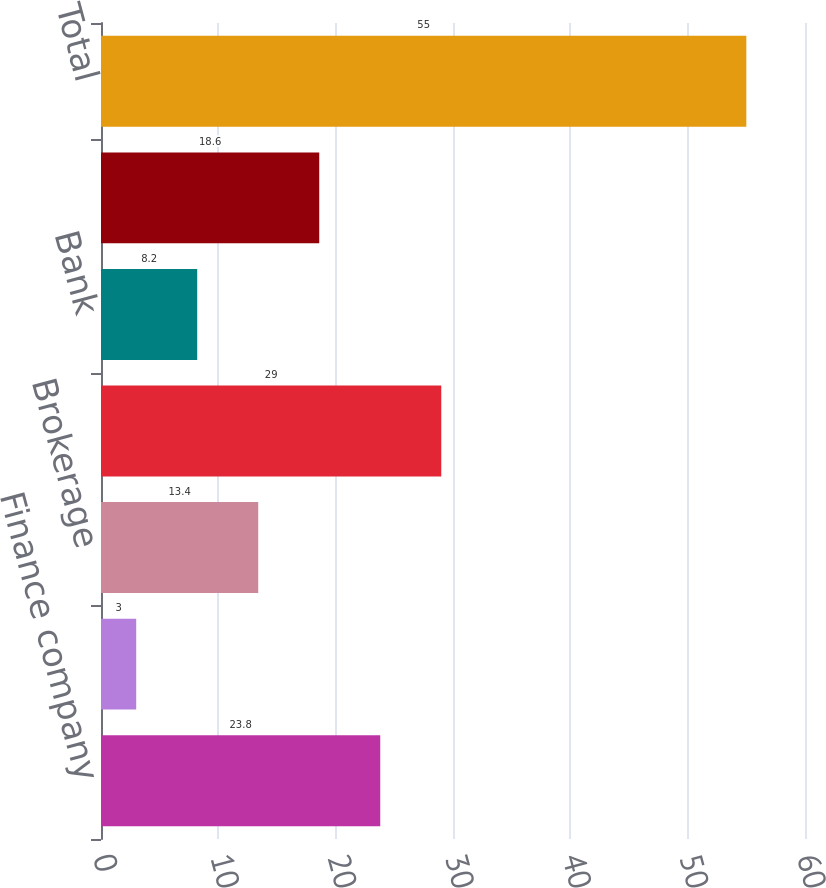Convert chart. <chart><loc_0><loc_0><loc_500><loc_500><bar_chart><fcel>Finance company<fcel>Large international insurer<fcel>Brokerage<fcel>Exchange traded<fcel>Bank<fcel>Mortgage association<fcel>Total<nl><fcel>23.8<fcel>3<fcel>13.4<fcel>29<fcel>8.2<fcel>18.6<fcel>55<nl></chart> 